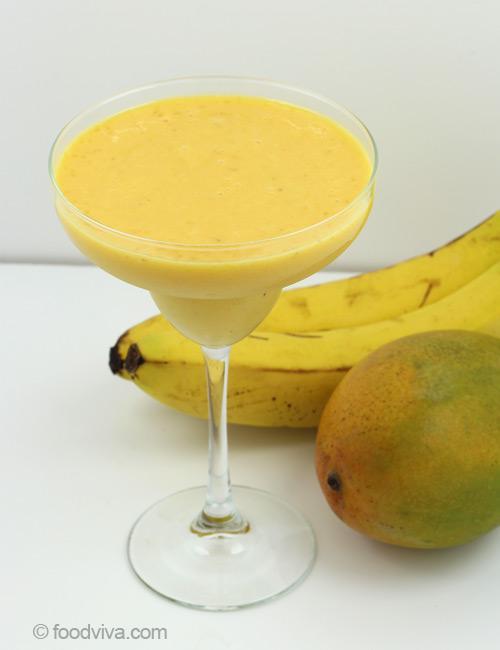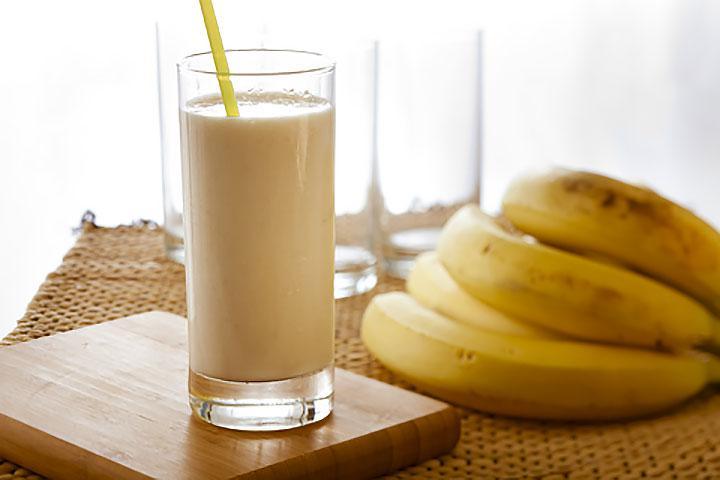The first image is the image on the left, the second image is the image on the right. Given the left and right images, does the statement "An image includes a smoothie in a glass with a straw and garnish, in front of a bunch of bananas." hold true? Answer yes or no. Yes. The first image is the image on the left, the second image is the image on the right. Analyze the images presented: Is the assertion "Each image includes a creamy drink in a glass with a straw in it, and one image includes a slice of banana as garnish on the rim of the glass." valid? Answer yes or no. No. The first image is the image on the left, the second image is the image on the right. Given the left and right images, does the statement "The right image contains a smoothie drink next to at least four bananas." hold true? Answer yes or no. Yes. The first image is the image on the left, the second image is the image on the right. Examine the images to the left and right. Is the description "The left image contains one smoothie with a small banana slice in the rim of its glass." accurate? Answer yes or no. No. 